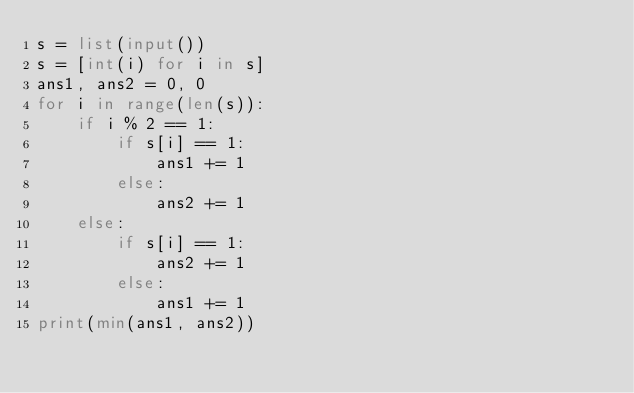Convert code to text. <code><loc_0><loc_0><loc_500><loc_500><_Python_>s = list(input())
s = [int(i) for i in s]
ans1, ans2 = 0, 0
for i in range(len(s)):
    if i % 2 == 1:
        if s[i] == 1:
            ans1 += 1
        else:
            ans2 += 1
    else:
        if s[i] == 1:
            ans2 += 1
        else:
            ans1 += 1
print(min(ans1, ans2))
</code> 